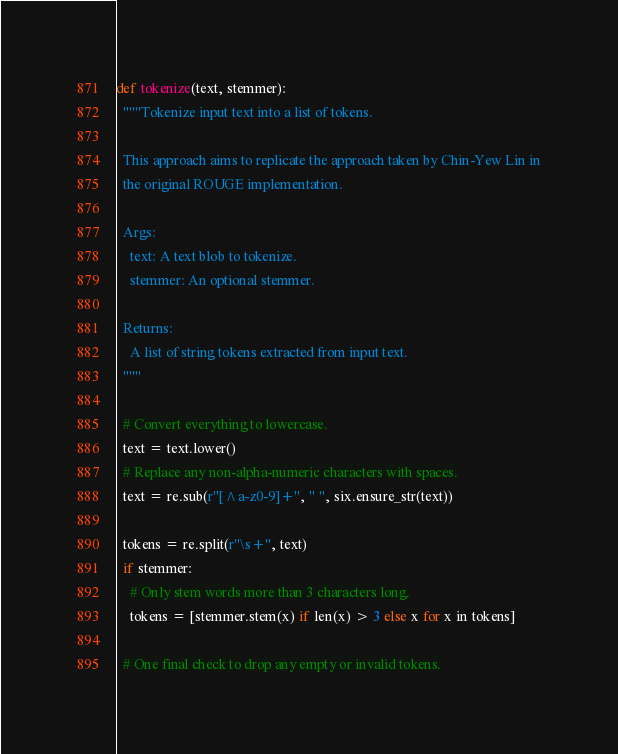Convert code to text. <code><loc_0><loc_0><loc_500><loc_500><_Python_>

def tokenize(text, stemmer):
  """Tokenize input text into a list of tokens.

  This approach aims to replicate the approach taken by Chin-Yew Lin in
  the original ROUGE implementation.

  Args:
    text: A text blob to tokenize.
    stemmer: An optional stemmer.

  Returns:
    A list of string tokens extracted from input text.
  """

  # Convert everything to lowercase.
  text = text.lower()
  # Replace any non-alpha-numeric characters with spaces.
  text = re.sub(r"[^a-z0-9]+", " ", six.ensure_str(text))

  tokens = re.split(r"\s+", text)
  if stemmer:
    # Only stem words more than 3 characters long.
    tokens = [stemmer.stem(x) if len(x) > 3 else x for x in tokens]

  # One final check to drop any empty or invalid tokens.</code> 